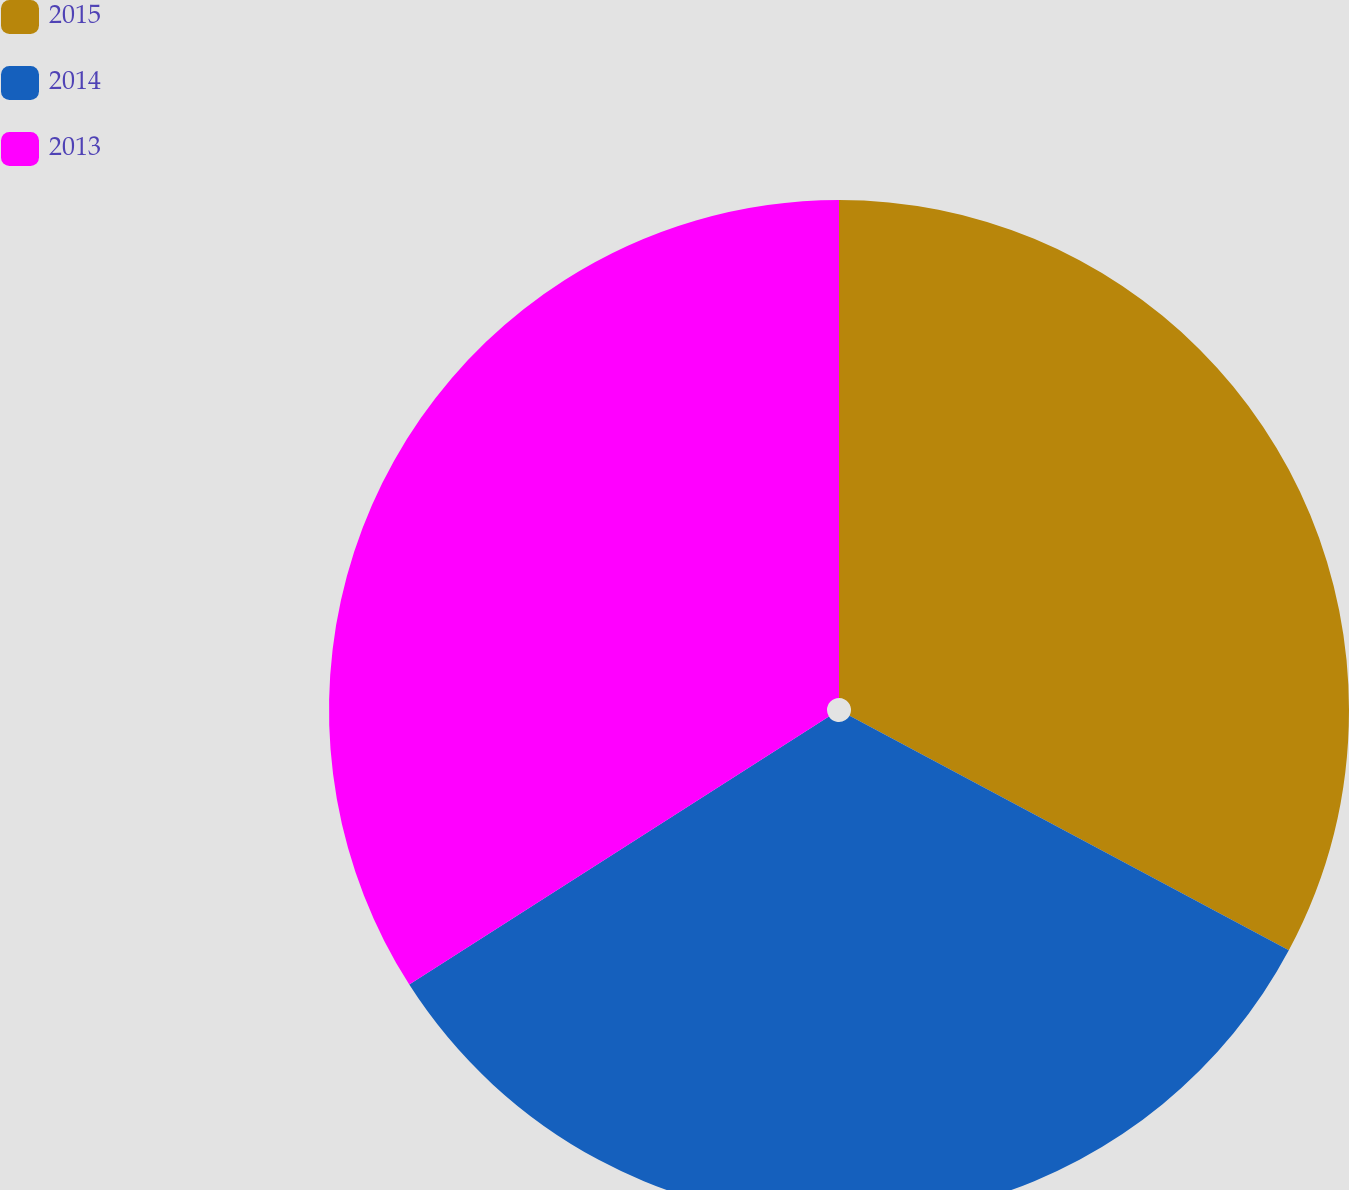Convert chart. <chart><loc_0><loc_0><loc_500><loc_500><pie_chart><fcel>2015<fcel>2014<fcel>2013<nl><fcel>32.81%<fcel>33.14%<fcel>34.05%<nl></chart> 